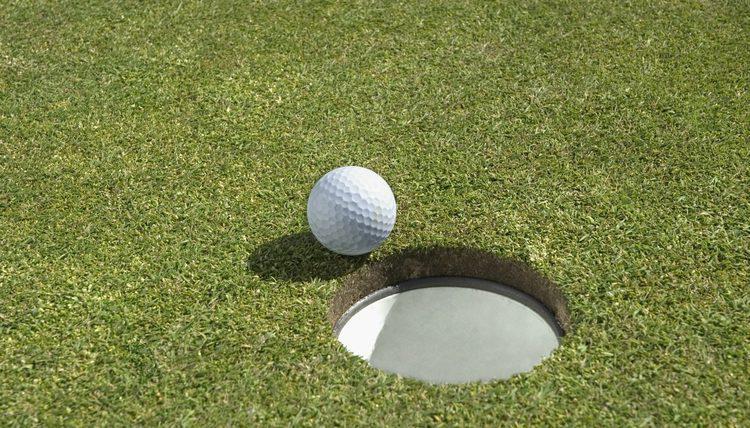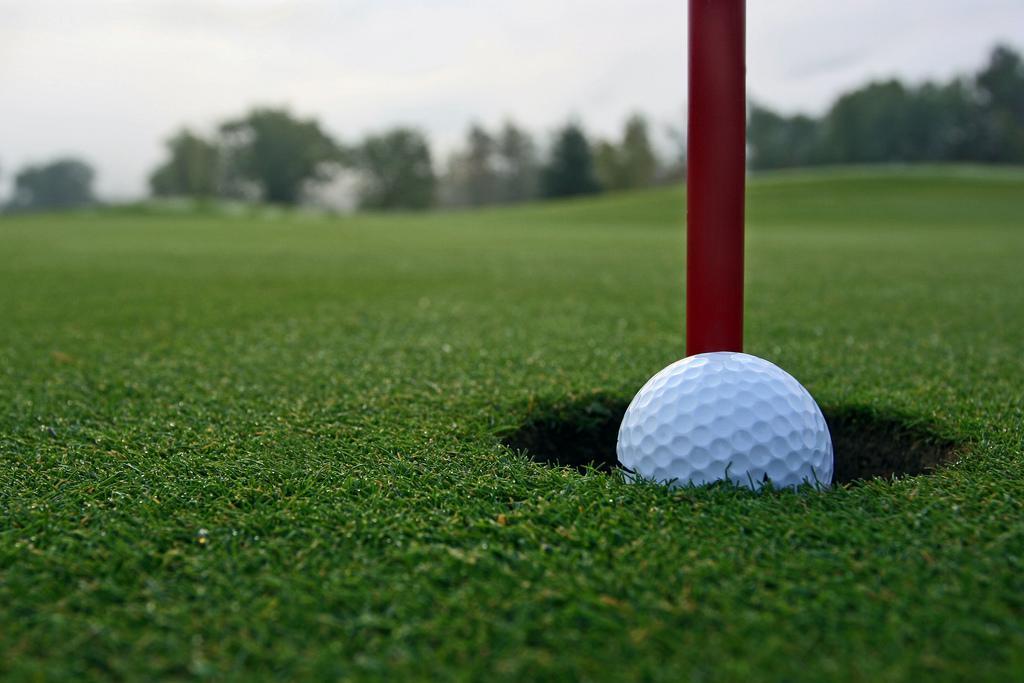The first image is the image on the left, the second image is the image on the right. Evaluate the accuracy of this statement regarding the images: "One image shows a golf ball at the edge of a hole that has a pole in it, but not inside the hole.". Is it true? Answer yes or no. No. 